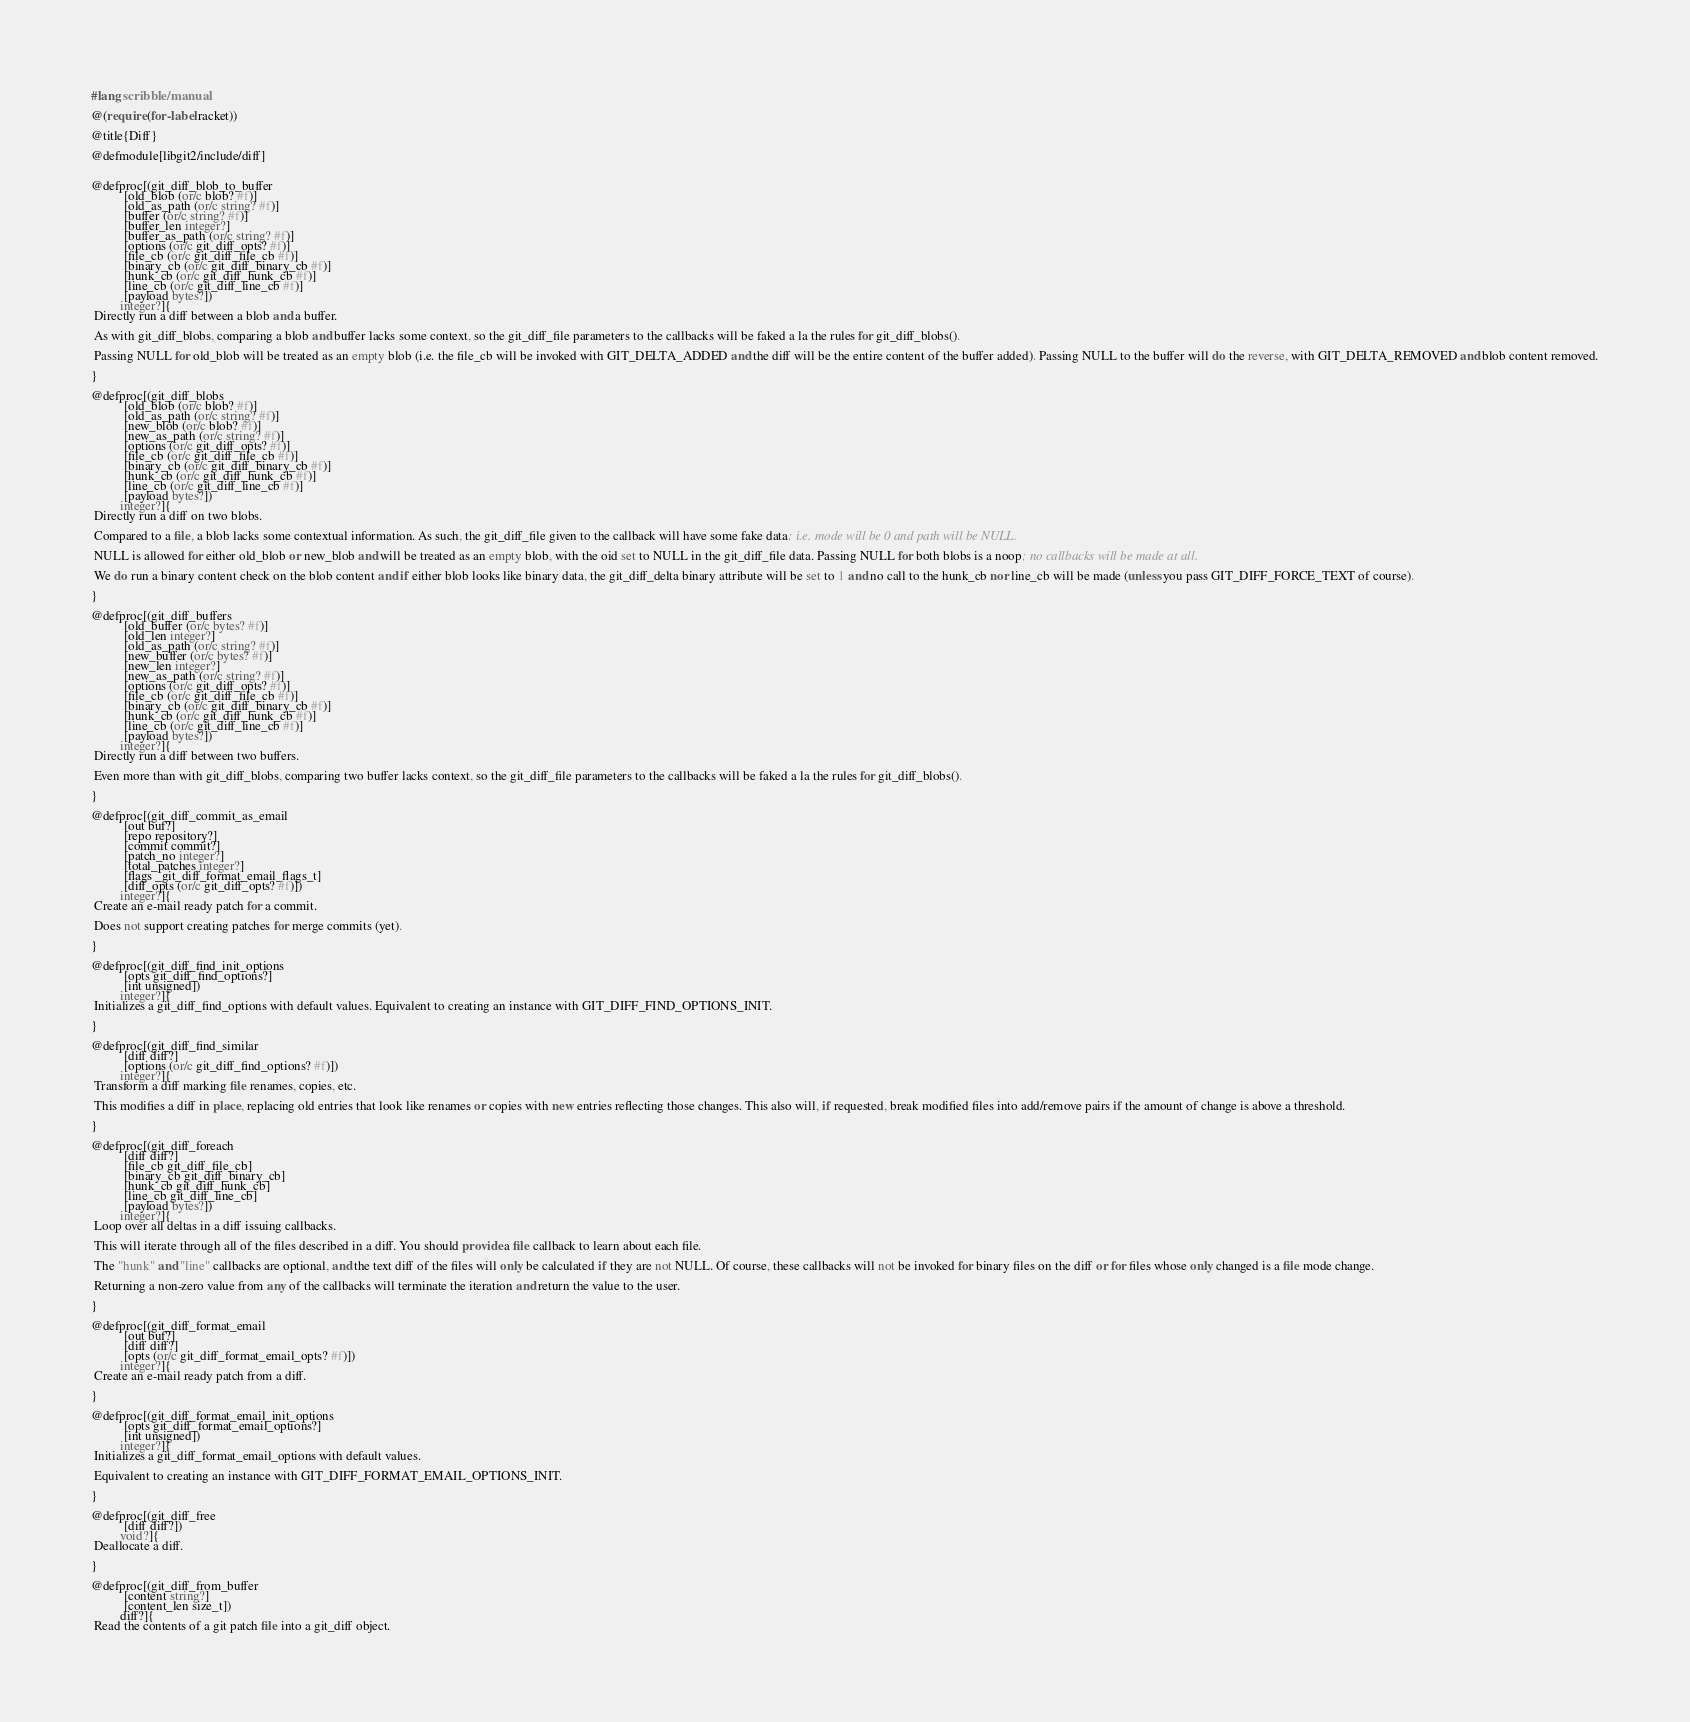<code> <loc_0><loc_0><loc_500><loc_500><_Racket_>
#lang scribble/manual

@(require (for-label racket))

@title{Diff}

@defmodule[libgit2/include/diff]


@defproc[(git_diff_blob_to_buffer
          [old_blob (or/c blob? #f)]
          [old_as_path (or/c string? #f)]
          [buffer (or/c string? #f)]
          [buffer_len integer?]
          [buffer_as_path (or/c string? #f)]
          [options (or/c git_diff_opts? #f)]
          [file_cb (or/c git_diff_file_cb #f)]
          [binary_cb (or/c git_diff_binary_cb #f)]
          [hunk_cb (or/c git_diff_hunk_cb #f)]
          [line_cb (or/c git_diff_line_cb #f)]
          [payload bytes?])
         integer?]{
 Directly run a diff between a blob and a buffer.

 As with git_diff_blobs, comparing a blob and buffer lacks some context, so the git_diff_file parameters to the callbacks will be faked a la the rules for git_diff_blobs().

 Passing NULL for old_blob will be treated as an empty blob (i.e. the file_cb will be invoked with GIT_DELTA_ADDED and the diff will be the entire content of the buffer added). Passing NULL to the buffer will do the reverse, with GIT_DELTA_REMOVED and blob content removed.

}

@defproc[(git_diff_blobs
          [old_blob (or/c blob? #f)]
          [old_as_path (or/c string? #f)]
          [new_blob (or/c blob? #f)]
          [new_as_path (or/c string? #f)]
          [options (or/c git_diff_opts? #f)]
          [file_cb (or/c git_diff_file_cb #f)]
          [binary_cb (or/c git_diff_binary_cb #f)]
          [hunk_cb (or/c git_diff_hunk_cb #f)]
          [line_cb (or/c git_diff_line_cb #f)]
          [payload bytes?])
         integer?]{
 Directly run a diff on two blobs.

 Compared to a file, a blob lacks some contextual information. As such, the git_diff_file given to the callback will have some fake data; i.e. mode will be 0 and path will be NULL.

 NULL is allowed for either old_blob or new_blob and will be treated as an empty blob, with the oid set to NULL in the git_diff_file data. Passing NULL for both blobs is a noop; no callbacks will be made at all.

 We do run a binary content check on the blob content and if either blob looks like binary data, the git_diff_delta binary attribute will be set to 1 and no call to the hunk_cb nor line_cb will be made (unless you pass GIT_DIFF_FORCE_TEXT of course).

}

@defproc[(git_diff_buffers
          [old_buffer (or/c bytes? #f)]
          [old_len integer?]
          [old_as_path (or/c string? #f)]
          [new_buffer (or/c bytes? #f)]
          [new_len integer?]
          [new_as_path (or/c string? #f)]
          [options (or/c git_diff_opts? #f)]
          [file_cb (or/c git_diff_file_cb #f)]
          [binary_cb (or/c git_diff_binary_cb #f)]
          [hunk_cb (or/c git_diff_hunk_cb #f)]
          [line_cb (or/c git_diff_line_cb #f)]
          [payload bytes?])
         integer?]{
 Directly run a diff between two buffers.

 Even more than with git_diff_blobs, comparing two buffer lacks context, so the git_diff_file parameters to the callbacks will be faked a la the rules for git_diff_blobs().

}

@defproc[(git_diff_commit_as_email
          [out buf?]
          [repo repository?]
          [commit commit?]
          [patch_no integer?]
          [total_patches integer?]
          [flags _git_diff_format_email_flags_t]
          [diff_opts (or/c git_diff_opts? #f)])
         integer?]{
 Create an e-mail ready patch for a commit.

 Does not support creating patches for merge commits (yet).

}

@defproc[(git_diff_find_init_options
          [opts git_diff_find_options?]
          [int unsigned])
         integer?]{
 Initializes a git_diff_find_options with default values. Equivalent to creating an instance with GIT_DIFF_FIND_OPTIONS_INIT.

}

@defproc[(git_diff_find_similar
          [diff diff?]
          [options (or/c git_diff_find_options? #f)])
         integer?]{
 Transform a diff marking file renames, copies, etc.

 This modifies a diff in place, replacing old entries that look like renames or copies with new entries reflecting those changes. This also will, if requested, break modified files into add/remove pairs if the amount of change is above a threshold.

}

@defproc[(git_diff_foreach
          [diff diff?]
          [file_cb git_diff_file_cb]
          [binary_cb git_diff_binary_cb]
          [hunk_cb git_diff_hunk_cb]
          [line_cb git_diff_line_cb]
          [payload bytes?])
         integer?]{
 Loop over all deltas in a diff issuing callbacks.

 This will iterate through all of the files described in a diff. You should provide a file callback to learn about each file.

 The "hunk" and "line" callbacks are optional, and the text diff of the files will only be calculated if they are not NULL. Of course, these callbacks will not be invoked for binary files on the diff or for files whose only changed is a file mode change.

 Returning a non-zero value from any of the callbacks will terminate the iteration and return the value to the user.

}

@defproc[(git_diff_format_email
          [out buf?]
          [diff diff?]
          [opts (or/c git_diff_format_email_opts? #f)])
         integer?]{
 Create an e-mail ready patch from a diff.

}

@defproc[(git_diff_format_email_init_options
          [opts git_diff_format_email_options?]
          [int unsigned])
         integer?]{
 Initializes a git_diff_format_email_options with default values.

 Equivalent to creating an instance with GIT_DIFF_FORMAT_EMAIL_OPTIONS_INIT.

}

@defproc[(git_diff_free
          [diff diff?])
         void?]{
 Deallocate a diff.

}

@defproc[(git_diff_from_buffer
          [content string?]
          [content_len size_t])
         diff?]{
 Read the contents of a git patch file into a git_diff object.
</code> 